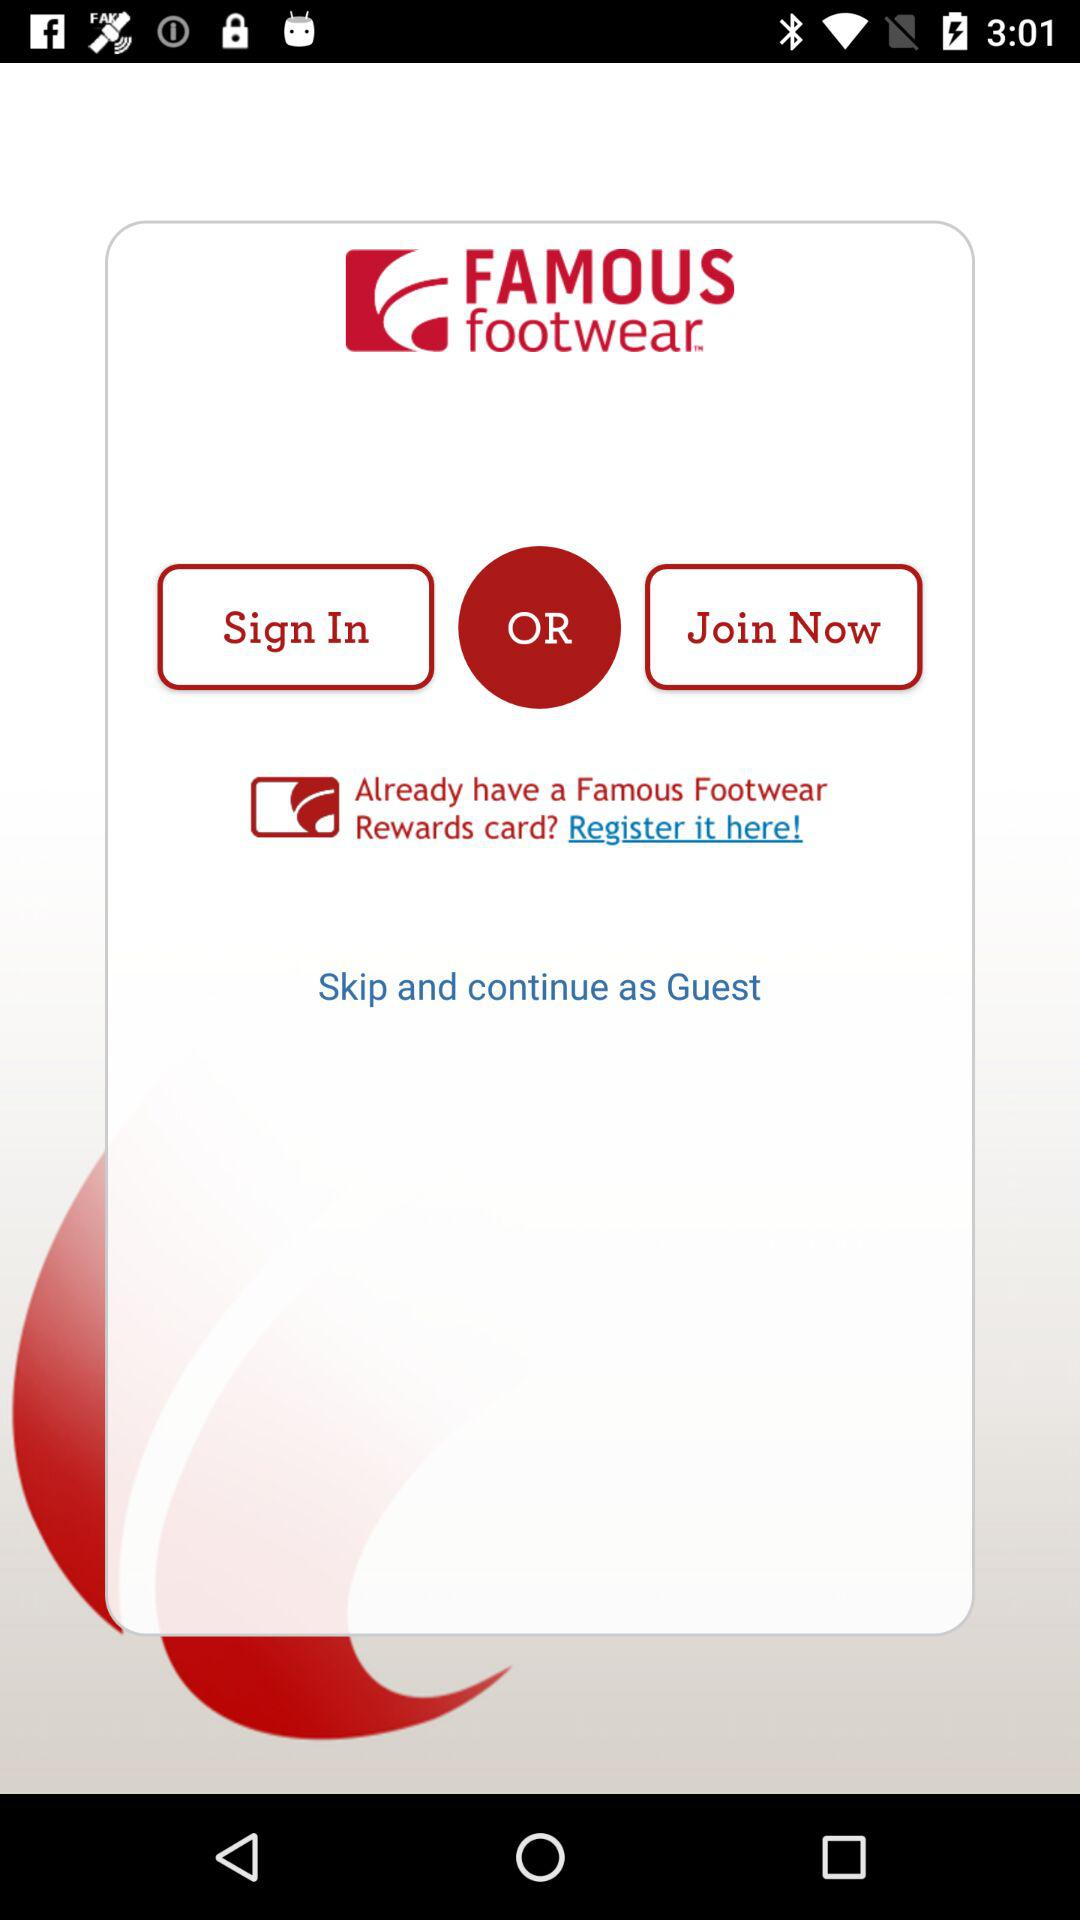What is the app name? The app name is "FAMOUS footwear". 